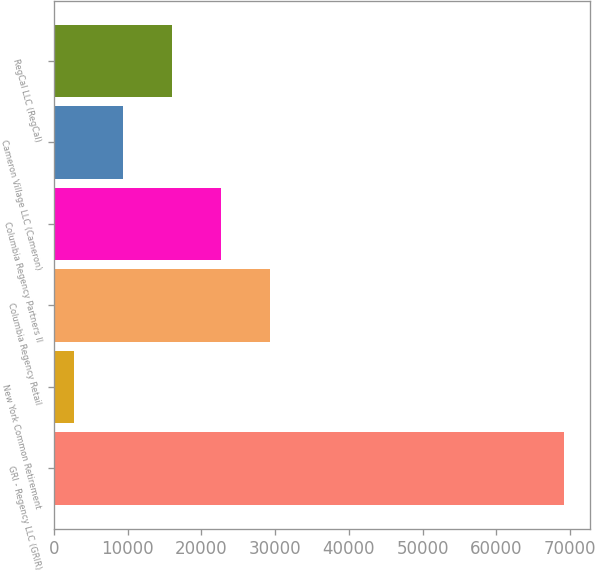Convert chart. <chart><loc_0><loc_0><loc_500><loc_500><bar_chart><fcel>GRI - Regency LLC (GRIR)<fcel>New York Common Retirement<fcel>Columbia Regency Retail<fcel>Columbia Regency Partners II<fcel>Cameron Village LLC (Cameron)<fcel>RegCal LLC (RegCal)<nl><fcel>69211<fcel>2757<fcel>29338.6<fcel>22693.2<fcel>9402.4<fcel>16047.8<nl></chart> 